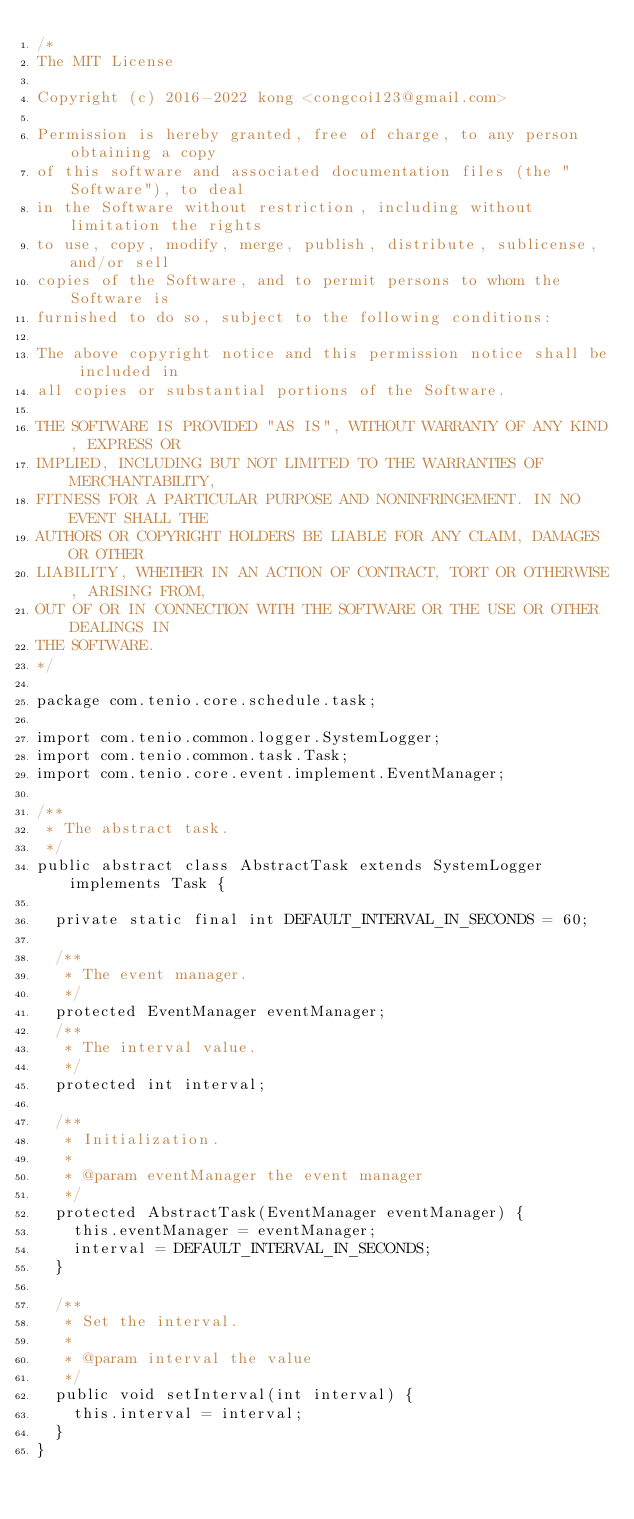<code> <loc_0><loc_0><loc_500><loc_500><_Java_>/*
The MIT License

Copyright (c) 2016-2022 kong <congcoi123@gmail.com>

Permission is hereby granted, free of charge, to any person obtaining a copy
of this software and associated documentation files (the "Software"), to deal
in the Software without restriction, including without limitation the rights
to use, copy, modify, merge, publish, distribute, sublicense, and/or sell
copies of the Software, and to permit persons to whom the Software is
furnished to do so, subject to the following conditions:

The above copyright notice and this permission notice shall be included in
all copies or substantial portions of the Software.

THE SOFTWARE IS PROVIDED "AS IS", WITHOUT WARRANTY OF ANY KIND, EXPRESS OR
IMPLIED, INCLUDING BUT NOT LIMITED TO THE WARRANTIES OF MERCHANTABILITY,
FITNESS FOR A PARTICULAR PURPOSE AND NONINFRINGEMENT. IN NO EVENT SHALL THE
AUTHORS OR COPYRIGHT HOLDERS BE LIABLE FOR ANY CLAIM, DAMAGES OR OTHER
LIABILITY, WHETHER IN AN ACTION OF CONTRACT, TORT OR OTHERWISE, ARISING FROM,
OUT OF OR IN CONNECTION WITH THE SOFTWARE OR THE USE OR OTHER DEALINGS IN
THE SOFTWARE.
*/

package com.tenio.core.schedule.task;

import com.tenio.common.logger.SystemLogger;
import com.tenio.common.task.Task;
import com.tenio.core.event.implement.EventManager;

/**
 * The abstract task.
 */
public abstract class AbstractTask extends SystemLogger implements Task {

  private static final int DEFAULT_INTERVAL_IN_SECONDS = 60;

  /**
   * The event manager.
   */
  protected EventManager eventManager;
  /**
   * The interval value.
   */
  protected int interval;

  /**
   * Initialization.
   *
   * @param eventManager the event manager
   */
  protected AbstractTask(EventManager eventManager) {
    this.eventManager = eventManager;
    interval = DEFAULT_INTERVAL_IN_SECONDS;
  }

  /**
   * Set the interval.
   *
   * @param interval the value
   */
  public void setInterval(int interval) {
    this.interval = interval;
  }
}
</code> 